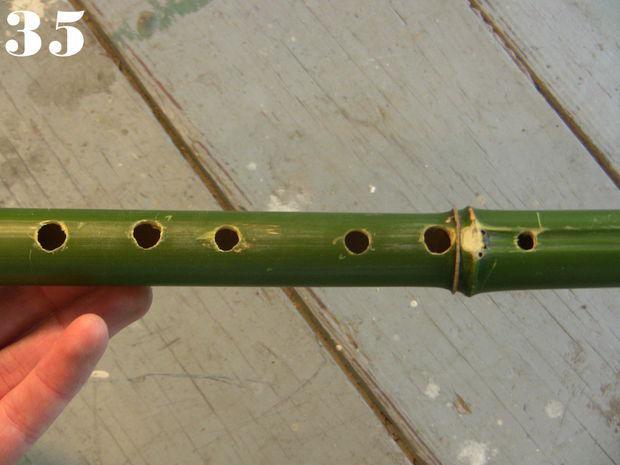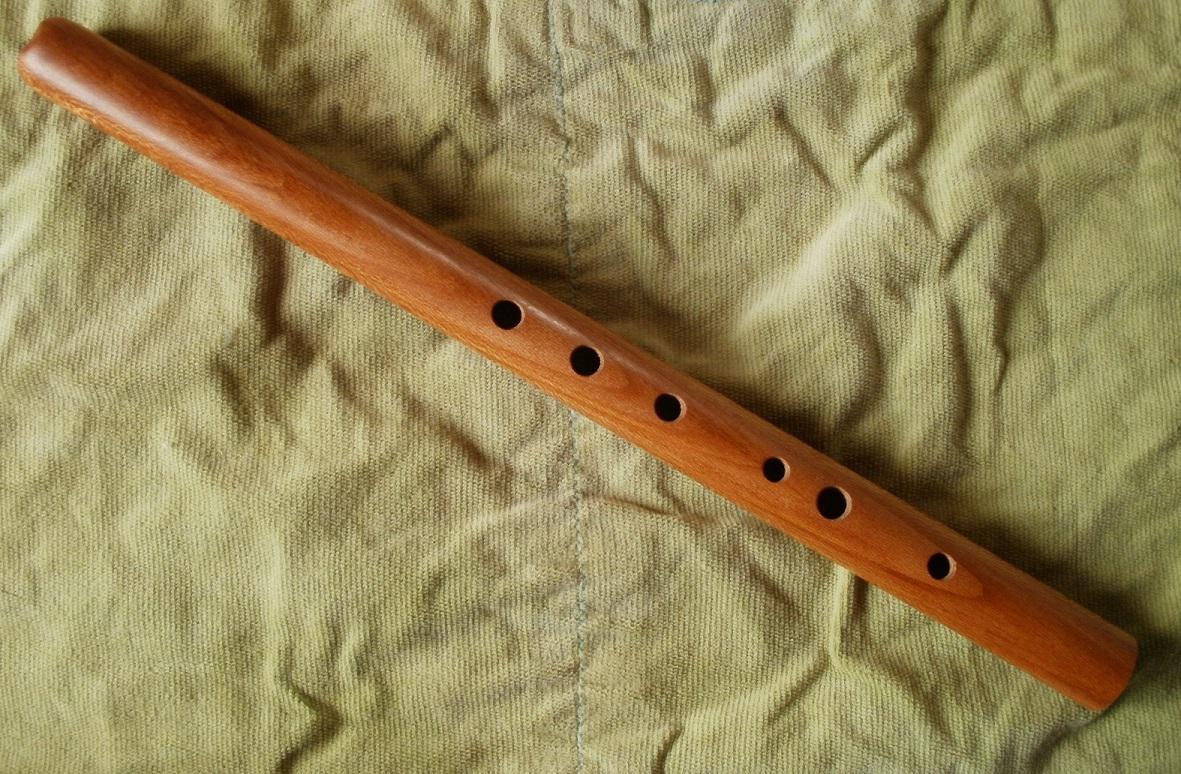The first image is the image on the left, the second image is the image on the right. Examine the images to the left and right. Is the description "There is exactly one flute in the right image." accurate? Answer yes or no. Yes. The first image is the image on the left, the second image is the image on the right. Evaluate the accuracy of this statement regarding the images: "The combined images contain exactly five flute-related objects.". Is it true? Answer yes or no. No. 